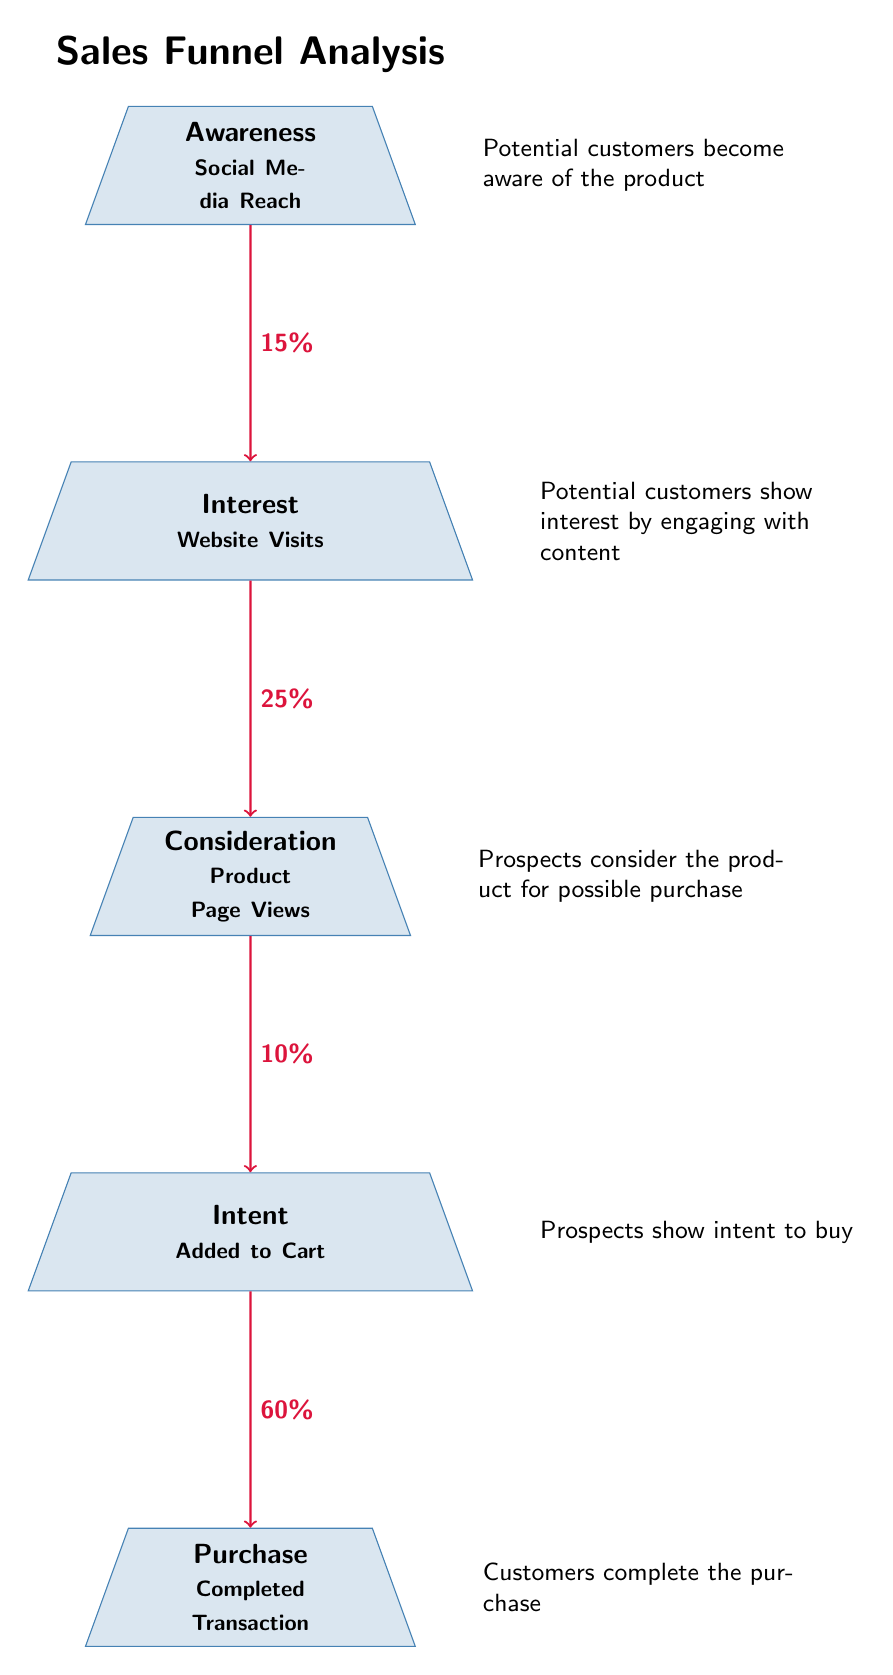What is the conversion rate from Awareness to Interest? The arrow between the Awareness and Interest stages indicates a conversion rate of 15%, which shows the percentage of customers who move from awareness to showing interest.
Answer: 15% How many stages are there in the sales funnel? The diagram displays five distinct stages: Awareness, Interest, Consideration, Intent, and Purchase, indicating the various steps prospective customers go through.
Answer: 5 What percentage of interested users proceed to consideration? The arrow from Interest to Consideration shows a conversion rate of 25%, representing the proportion of users who, after showing interest, move on to consider purchasing.
Answer: 25% Which stage has the highest conversion rate? The Intent to Purchase stage has a conversion rate of 60%, which is higher than the conversion rates of all other stages in the diagram, indicating it is the most successful transition point.
Answer: 60% What happens at the Purchase stage? The description next to the Purchase stage states that customers complete the purchase, signifying the final step in the sales funnel where a transaction is finalized.
Answer: Completed Transaction What is the relationship between Intent and Purchase? The arrow pointing from Intent to Purchase indicates that there is a 60% conversion rate, showcasing that a significant portion of users who indicate intent end up purchasing the product.
Answer: 60% What do potential customers experience in the Awareness stage? The explanation alongside the Awareness stage specifies that potential customers become aware of the product, which marks the entry point in the sales funnel.
Answer: Social Media Reach Which conversion rate shows the largest drop in the funnel? Reviewing the conversion rates, the transition from Consideration to Intent shows a drop to 10%, which in relation to the previous stage represents the largest decrease in percentage.
Answer: 10% What does the Interest stage indicate for potential customers? The description beside the Interest stage indicates that potential customers show interest by engaging with content, illustrating what occurs during this stage.
Answer: Engaging with content 